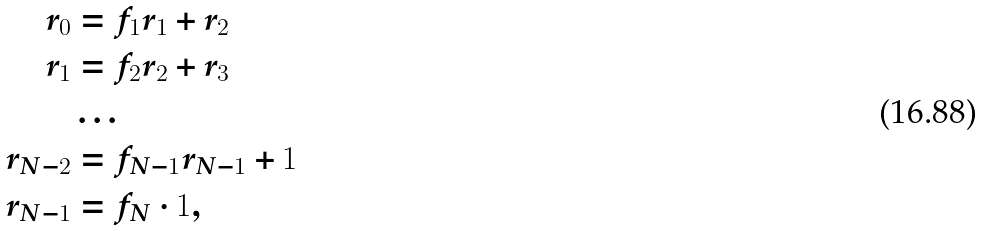<formula> <loc_0><loc_0><loc_500><loc_500>r _ { 0 } & = f _ { 1 } r _ { 1 } + r _ { 2 } \\ r _ { 1 } & = f _ { 2 } r _ { 2 } + r _ { 3 } \\ & \dots \\ r _ { N - 2 } & = f _ { N - 1 } r _ { N - 1 } + 1 \\ r _ { N - 1 } & = f _ { N } \cdot 1 ,</formula> 